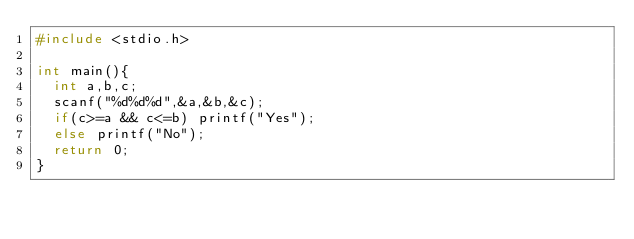Convert code to text. <code><loc_0><loc_0><loc_500><loc_500><_C_>#include <stdio.h>

int main(){
  int a,b,c;
  scanf("%d%d%d",&a,&b,&c);
  if(c>=a && c<=b) printf("Yes");
  else printf("No");
  return 0;
}</code> 